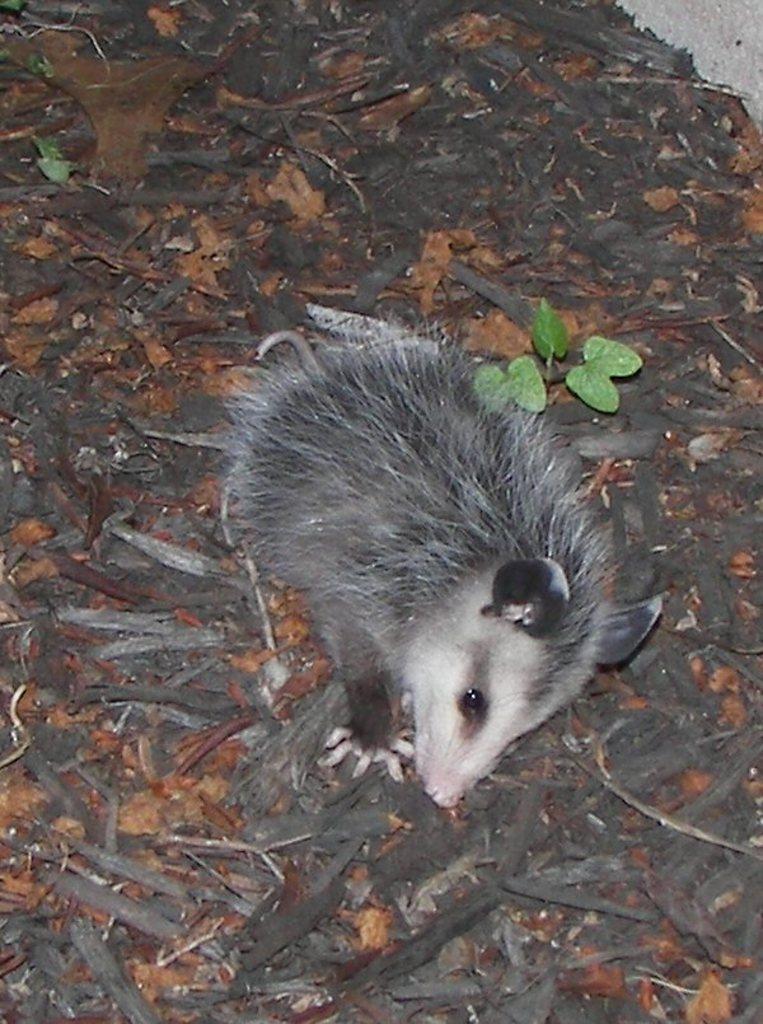How would you summarize this image in a sentence or two? In this image we can see an animal. There are leaves and wooden pieces on the land. 